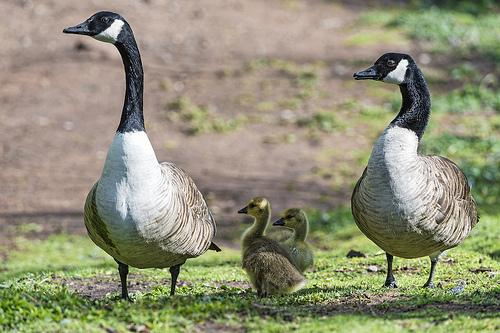Comment on the quality and focus of the photo. The photo has a slightly blurry background, with the birds and the green grassy area in focus. Describe the appearance and position of the baby birds in the image. The two little baby geese are brown and yellow, standing between their parents in the middle of the scene. Highlight the key features of the location in the image. The location features a large grassy area, patches of dirt, green vegetables, and a farmland in the background where the birds are standing. Provide a brief description of the scene depicted in the image. Two adult geese stand with their goslings on a grassy field, surrounded by patches of dirt and green vegetation in the background. Mention the types of birds in the picture and their position in relation to one another. There are two adult geese, one on the left and one on the right, and two baby geese in the middle, all standing close together. Describe the colors and unique features of the birds in the image. There is a black, white, and brown adult goose with its neck extended, and another adult goose with a bent neck, along with two yellow and brown goslings. Comment on the background elements in the picture. The background features farmland, green vegetables, and a large grassy area blending with a large area of dirt ground. Mention the types of ground surfaces seen in the image. There is green grass, brown dirt, and a small patch of darker dirt on the ground in the image. Describe the interaction between the adult and baby birds. The adult geese are watching over and standing near their baby geese, looking into the distance with their heads extended. Explain how the adult birds' postures differ in the image. One adult goose has its head fully extended up, while the other goose has its head down lower than the other with a bent neck. 